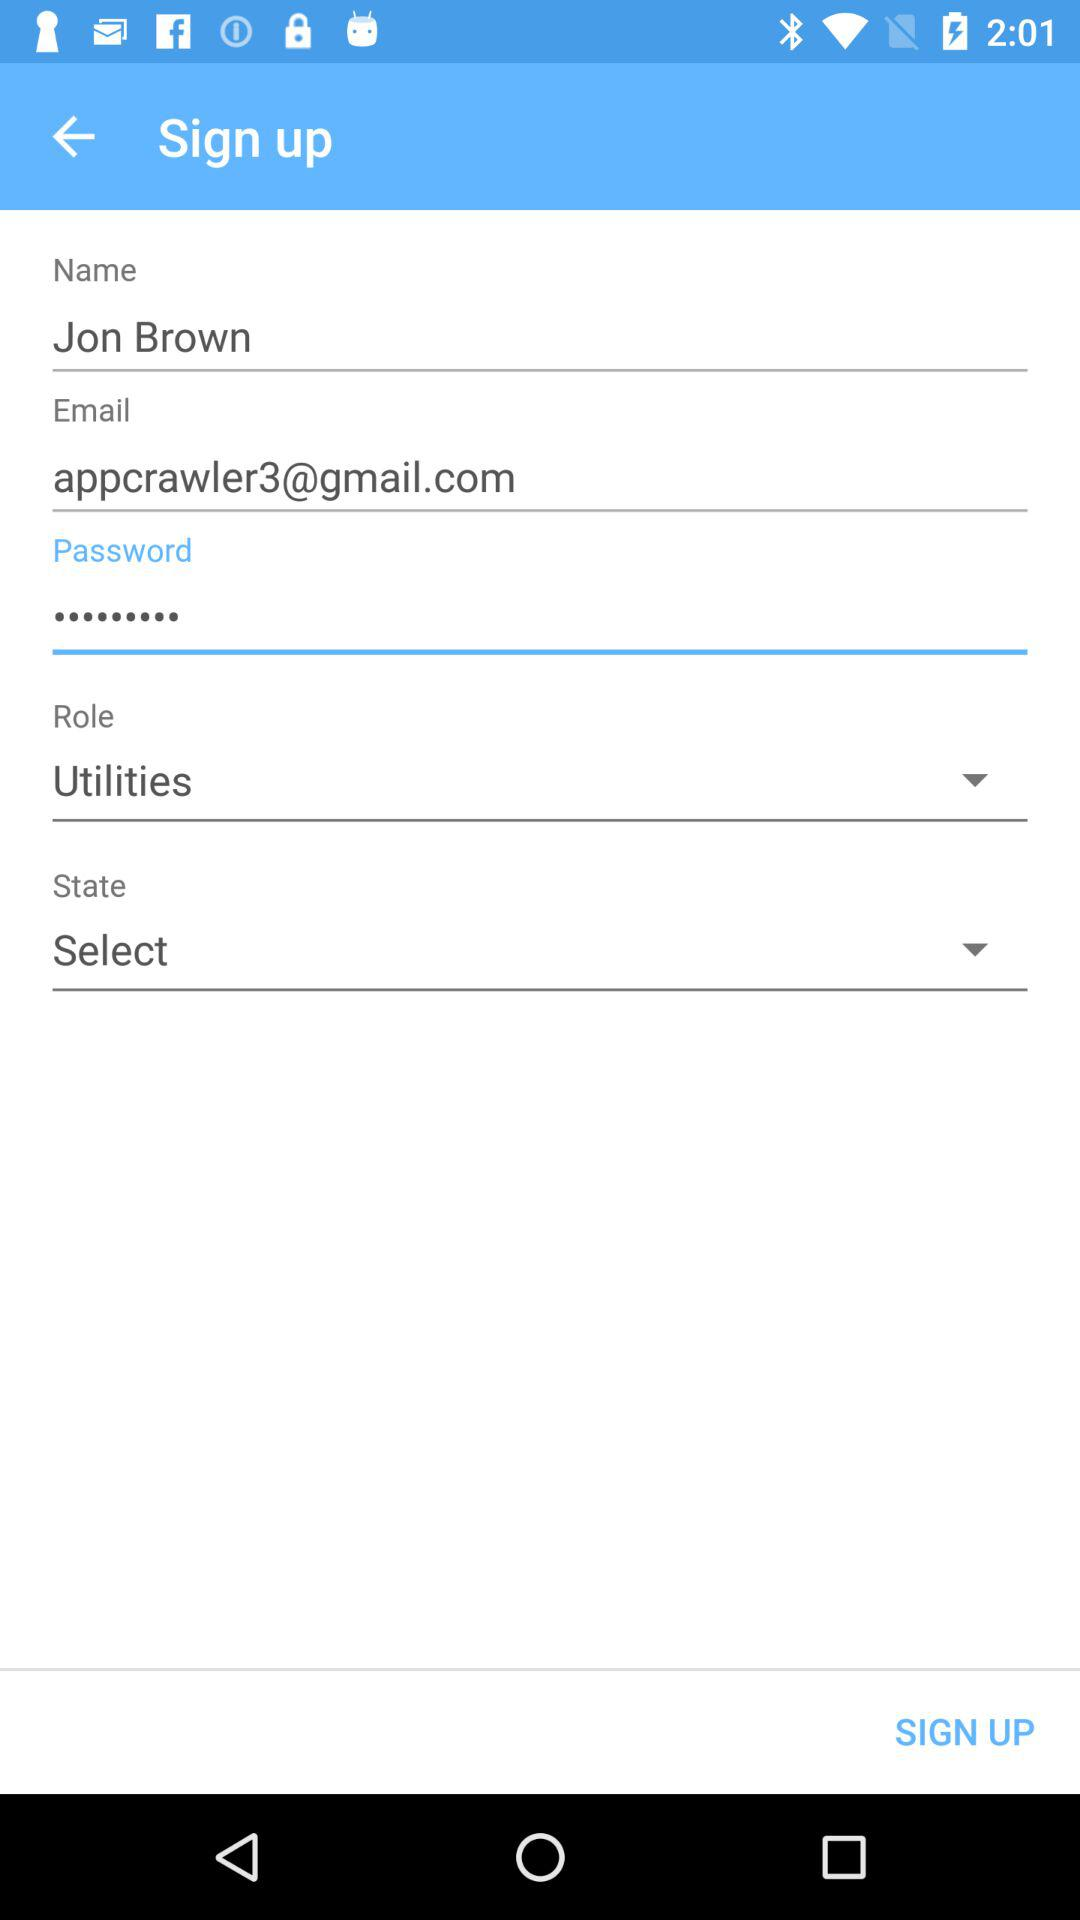What is the email account address? The email account address is appcrawler3@gmail.com. 